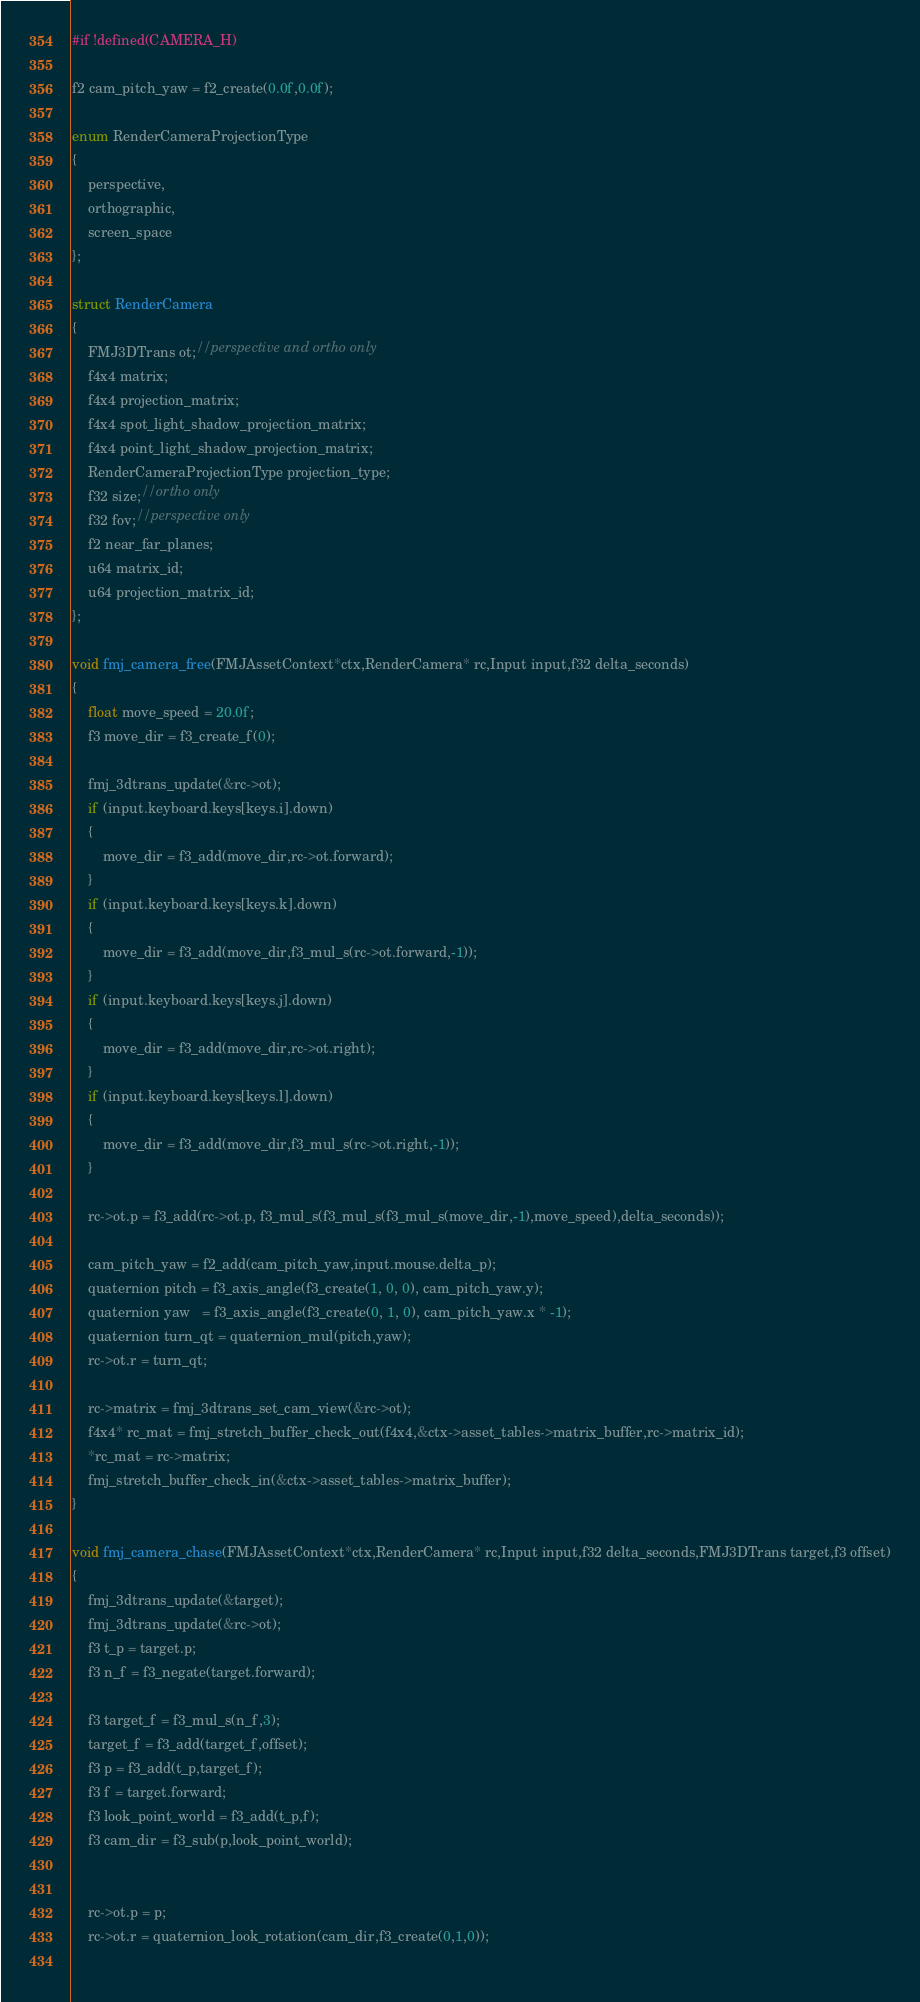Convert code to text. <code><loc_0><loc_0><loc_500><loc_500><_C_>#if !defined(CAMERA_H)

f2 cam_pitch_yaw = f2_create(0.0f,0.0f);

enum RenderCameraProjectionType
{
    perspective,
    orthographic,
    screen_space
};

struct RenderCamera
{
    FMJ3DTrans ot;//perspective and ortho only
    f4x4 matrix;
    f4x4 projection_matrix;
    f4x4 spot_light_shadow_projection_matrix;
    f4x4 point_light_shadow_projection_matrix;
    RenderCameraProjectionType projection_type;
    f32 size;//ortho only
    f32 fov;//perspective only
    f2 near_far_planes;
    u64 matrix_id;
    u64 projection_matrix_id;
};

void fmj_camera_free(FMJAssetContext*ctx,RenderCamera* rc,Input input,f32 delta_seconds)
{
    float move_speed = 20.0f;
    f3 move_dir = f3_create_f(0);

    fmj_3dtrans_update(&rc->ot);
    if (input.keyboard.keys[keys.i].down)
    {
        move_dir = f3_add(move_dir,rc->ot.forward);
    }
    if (input.keyboard.keys[keys.k].down)
    {
        move_dir = f3_add(move_dir,f3_mul_s(rc->ot.forward,-1));
    }
    if (input.keyboard.keys[keys.j].down)
    {
        move_dir = f3_add(move_dir,rc->ot.right);
    }
    if (input.keyboard.keys[keys.l].down)
    {
        move_dir = f3_add(move_dir,f3_mul_s(rc->ot.right,-1));
    }

    rc->ot.p = f3_add(rc->ot.p, f3_mul_s(f3_mul_s(f3_mul_s(move_dir,-1),move_speed),delta_seconds));
            
    cam_pitch_yaw = f2_add(cam_pitch_yaw,input.mouse.delta_p);
    quaternion pitch = f3_axis_angle(f3_create(1, 0, 0), cam_pitch_yaw.y);
    quaternion yaw   = f3_axis_angle(f3_create(0, 1, 0), cam_pitch_yaw.x * -1);
    quaternion turn_qt = quaternion_mul(pitch,yaw);        
    rc->ot.r = turn_qt;

    rc->matrix = fmj_3dtrans_set_cam_view(&rc->ot);
    f4x4* rc_mat = fmj_stretch_buffer_check_out(f4x4,&ctx->asset_tables->matrix_buffer,rc->matrix_id);
    *rc_mat = rc->matrix;
    fmj_stretch_buffer_check_in(&ctx->asset_tables->matrix_buffer);
}

void fmj_camera_chase(FMJAssetContext*ctx,RenderCamera* rc,Input input,f32 delta_seconds,FMJ3DTrans target,f3 offset)
{
    fmj_3dtrans_update(&target);
    fmj_3dtrans_update(&rc->ot);
    f3 t_p = target.p;
    f3 n_f = f3_negate(target.forward);
    
    f3 target_f = f3_mul_s(n_f,3);
    target_f = f3_add(target_f,offset);
    f3 p = f3_add(t_p,target_f);
    f3 f = target.forward;
    f3 look_point_world = f3_add(t_p,f);
    f3 cam_dir = f3_sub(p,look_point_world);

    
    rc->ot.p = p;
    rc->ot.r = quaternion_look_rotation(cam_dir,f3_create(0,1,0));
    </code> 